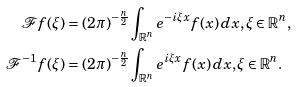Convert formula to latex. <formula><loc_0><loc_0><loc_500><loc_500>\mathcal { F } f ( \xi ) & = ( 2 \pi ) ^ { - \frac { n } { 2 } } \int _ { \mathbb { R } ^ { n } } e ^ { - i \xi x } f ( x ) \, d x , \xi \in \mathbb { R } ^ { n } , \\ \mathcal { F } ^ { - 1 } f ( \xi ) & = ( 2 \pi ) ^ { - \frac { n } { 2 } } \int _ { \mathbb { R } ^ { n } } e ^ { i \xi x } f ( x ) \, d x , \xi \in \mathbb { R } ^ { n } .</formula> 